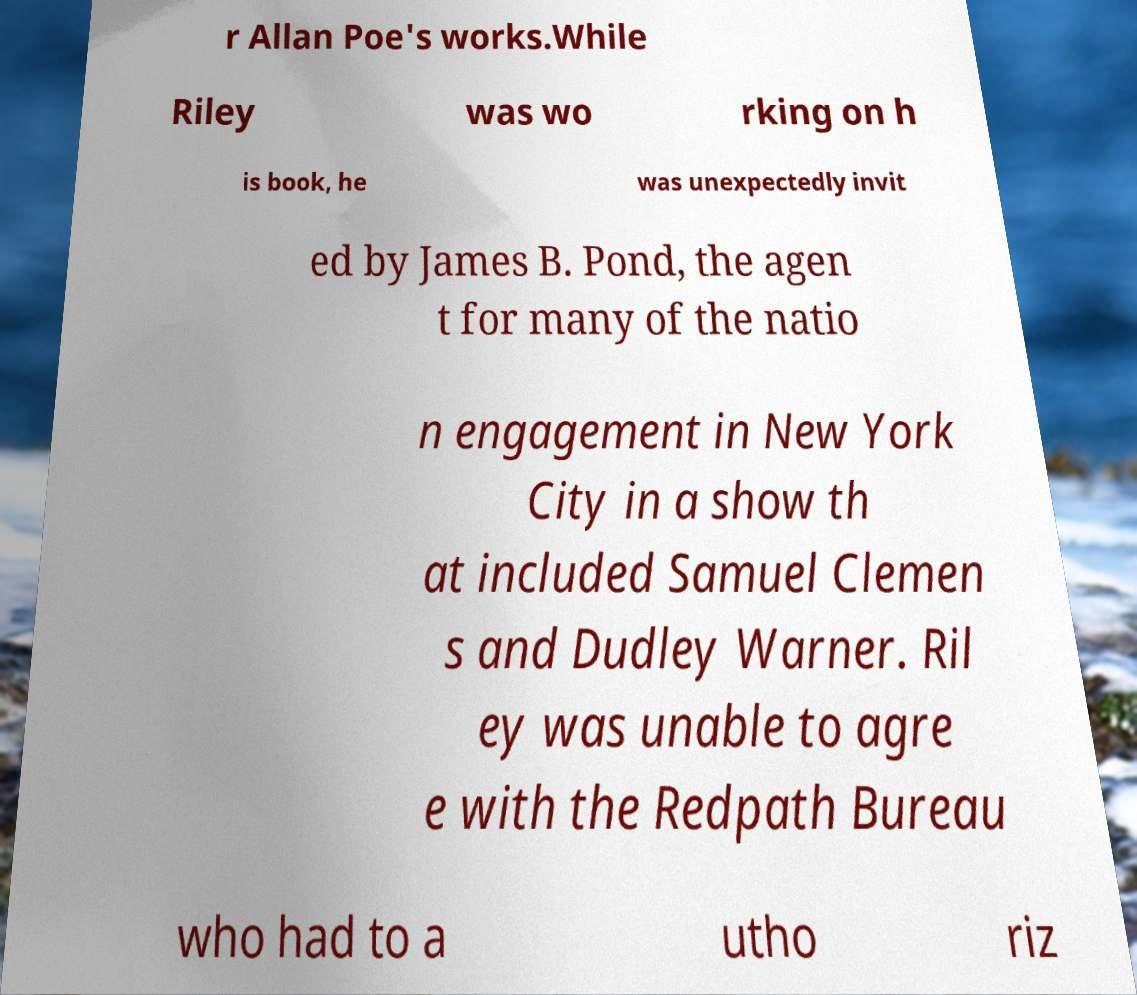Please read and relay the text visible in this image. What does it say? r Allan Poe's works.While Riley was wo rking on h is book, he was unexpectedly invit ed by James B. Pond, the agen t for many of the natio n engagement in New York City in a show th at included Samuel Clemen s and Dudley Warner. Ril ey was unable to agre e with the Redpath Bureau who had to a utho riz 